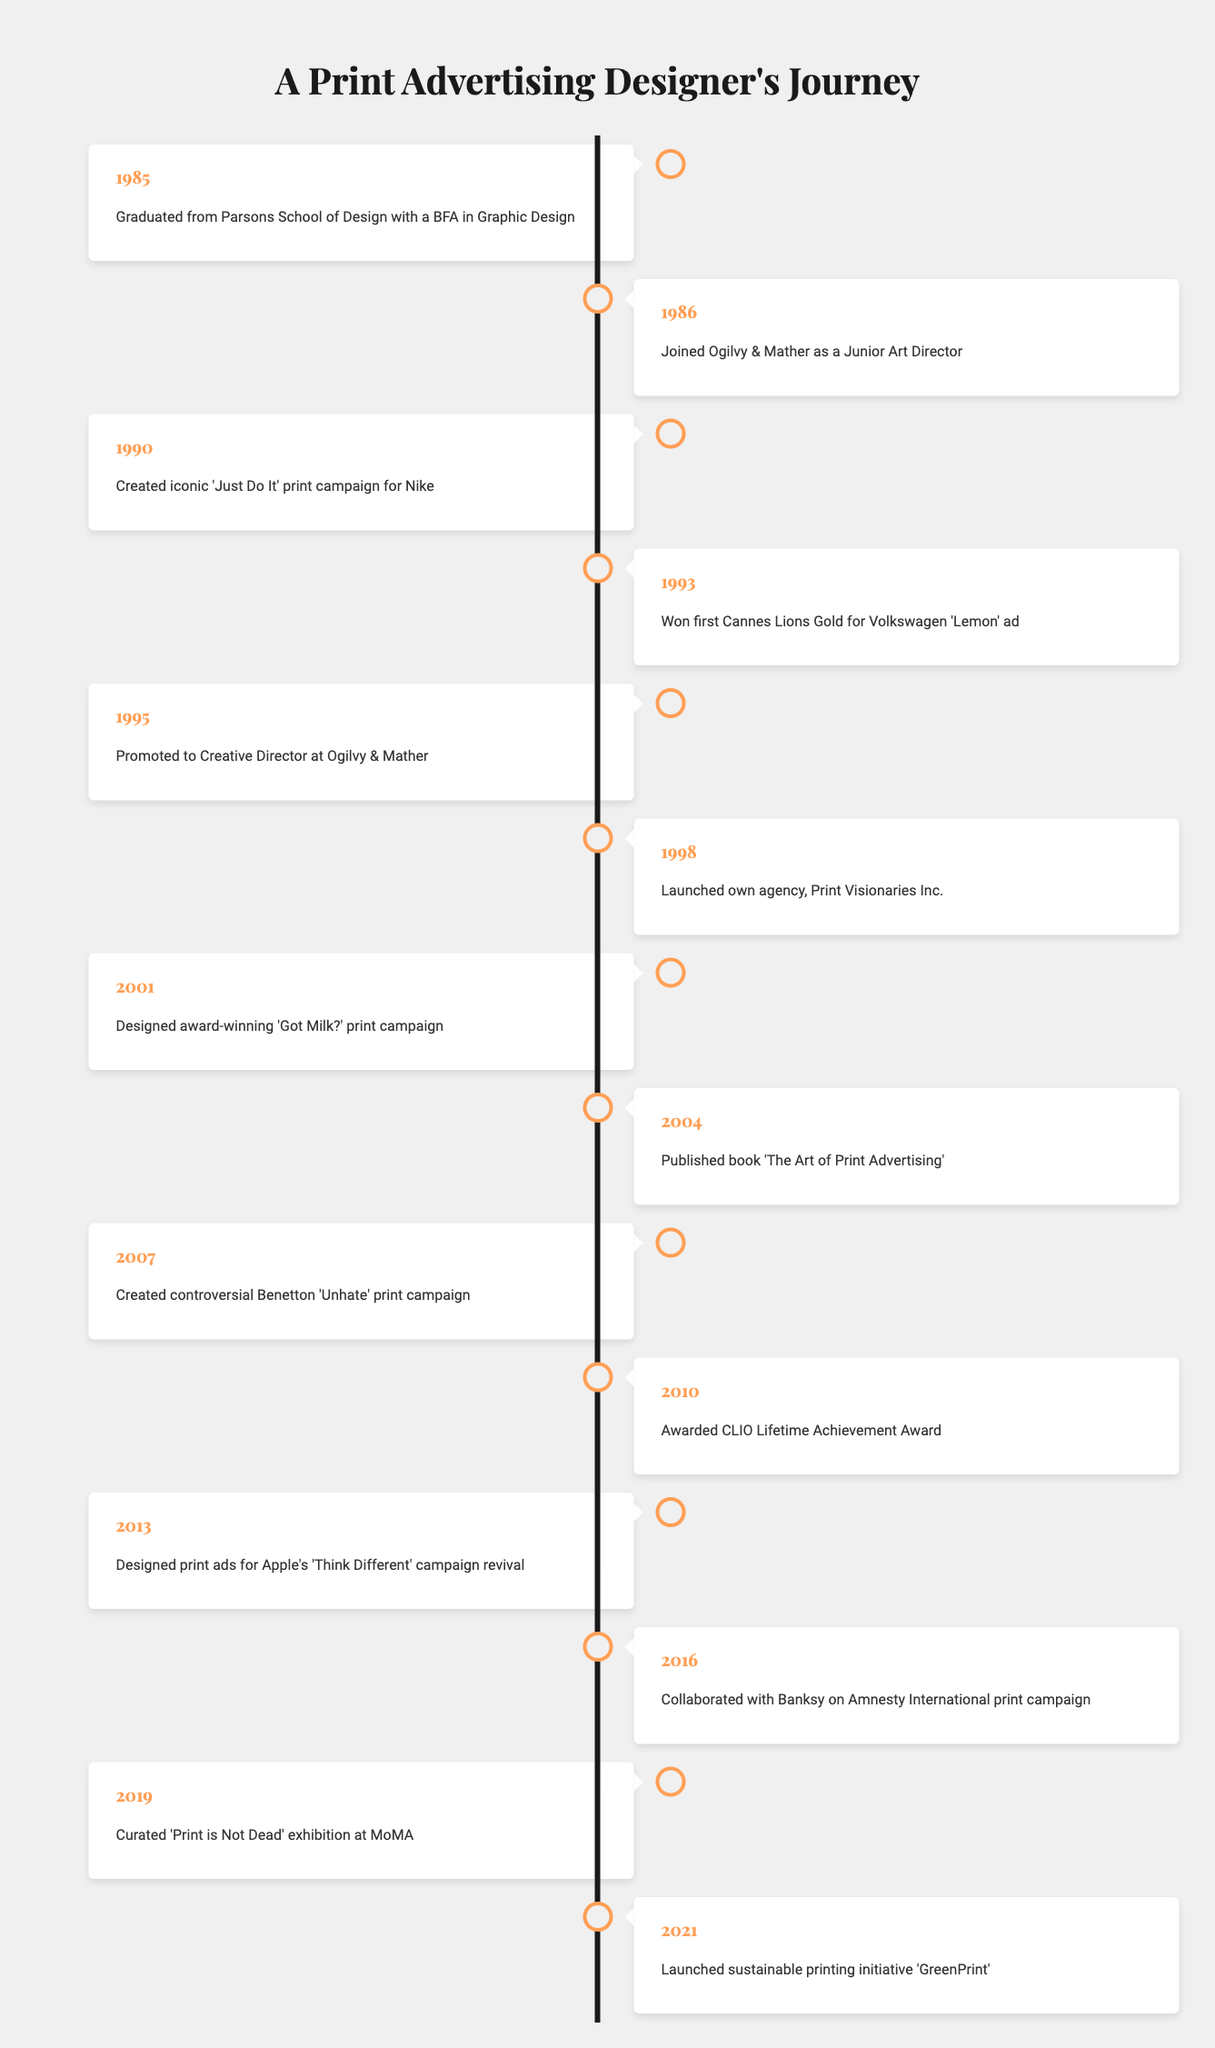What year did the designer graduate from Parsons School of Design? The timeline indicates the designer graduated in 1985.
Answer: 1985 What was the first print campaign created by the designer for Nike? According to the timeline, the designer created the iconic 'Just Do It' print campaign for Nike in 1990.
Answer: 'Just Do It' Which campaign won the designer their first Cannes Lions Gold? The designer won their first Cannes Lions Gold in 1993 for the Volkswagen 'Lemon' ad, as stated in the timeline.
Answer: Volkswagen 'Lemon' How many years did it take from graduating to launching their own agency? The designer graduated in 1985 and launched their agency in 1998. The difference is 1998 - 1985 = 13 years.
Answer: 13 years Did the designer receive any significant awards in 2010? The timeline shows that the designer was awarded the CLIO Lifetime Achievement Award in 2010.
Answer: Yes What event marks the beginning of the designer’s independent career? The launch of Print Visionaries Inc. in 1998 marks the beginning of the designer's independent career, based on the timeline.
Answer: Launch of Print Visionaries Inc Which print campaign involved a collaboration with Banksy? The designer collaborated with Banksy on an Amnesty International print campaign in 2016, according to the timeline.
Answer: Amnesty International In what year did the designer curate an exhibition at MoMA? The designer curated the 'Print is Not Dead' exhibition at MoMA in 2019, as per the timeline.
Answer: 2019 How many years are there between the designer's promotion to Creative Director and the CLIO Lifetime Achievement Award? The designer was promoted in 1995 and received the CLIO award in 2010. This is 2010 - 1995 = 15 years.
Answer: 15 years Which book did the designer publish, and in what year? The designer published the book 'The Art of Print Advertising' in 2004, as indicated in the timeline.
Answer: 'The Art of Print Advertising' in 2004 